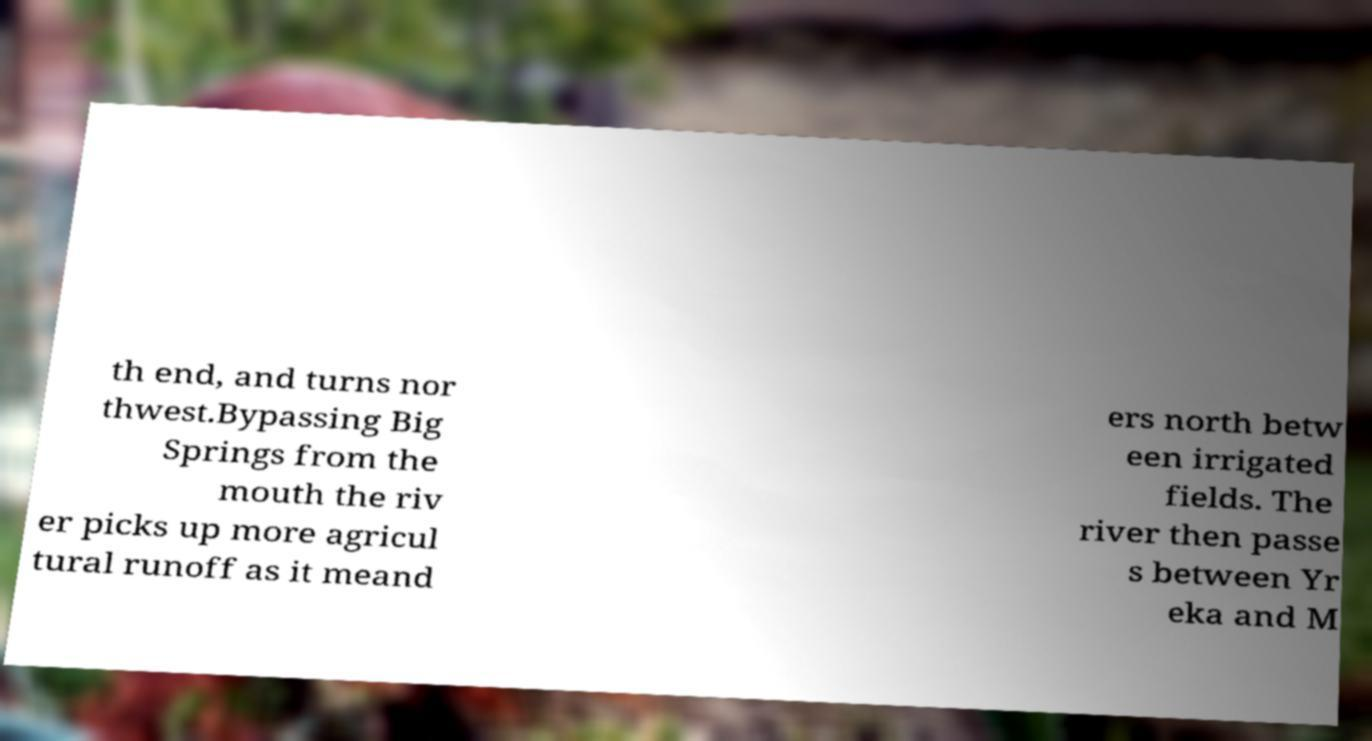Could you assist in decoding the text presented in this image and type it out clearly? th end, and turns nor thwest.Bypassing Big Springs from the mouth the riv er picks up more agricul tural runoff as it meand ers north betw een irrigated fields. The river then passe s between Yr eka and M 